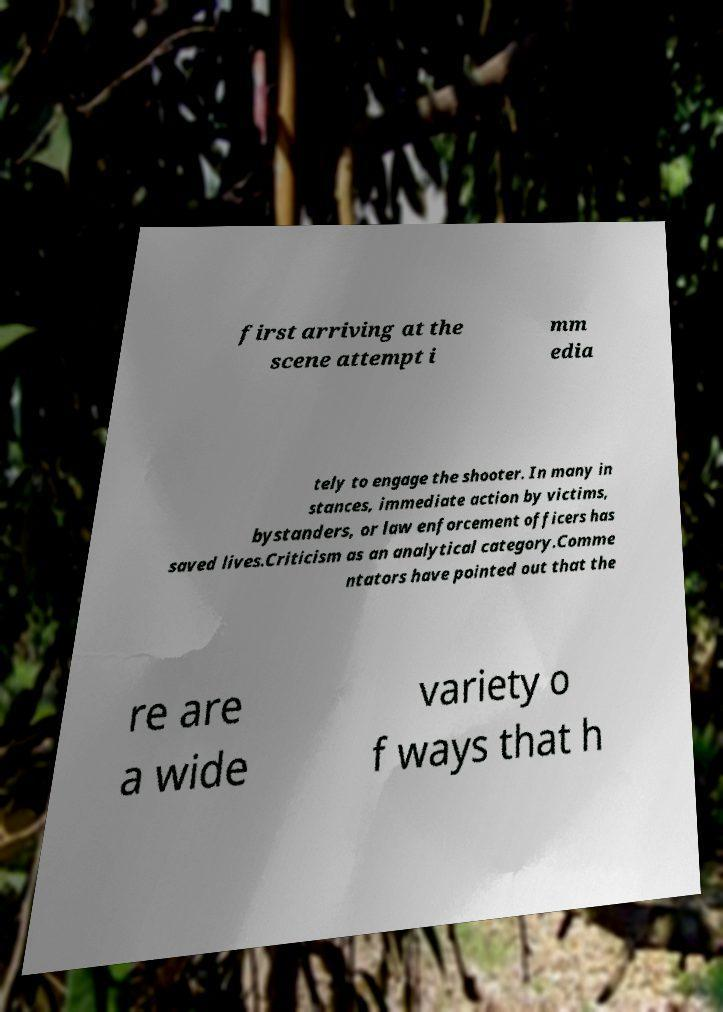I need the written content from this picture converted into text. Can you do that? first arriving at the scene attempt i mm edia tely to engage the shooter. In many in stances, immediate action by victims, bystanders, or law enforcement officers has saved lives.Criticism as an analytical category.Comme ntators have pointed out that the re are a wide variety o f ways that h 